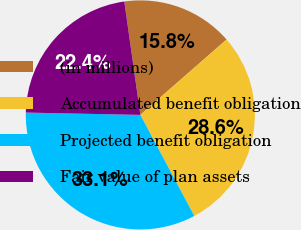Convert chart to OTSL. <chart><loc_0><loc_0><loc_500><loc_500><pie_chart><fcel>(in millions)<fcel>Accumulated benefit obligation<fcel>Projected benefit obligation<fcel>Fair value of plan assets<nl><fcel>15.8%<fcel>28.63%<fcel>33.13%<fcel>22.44%<nl></chart> 